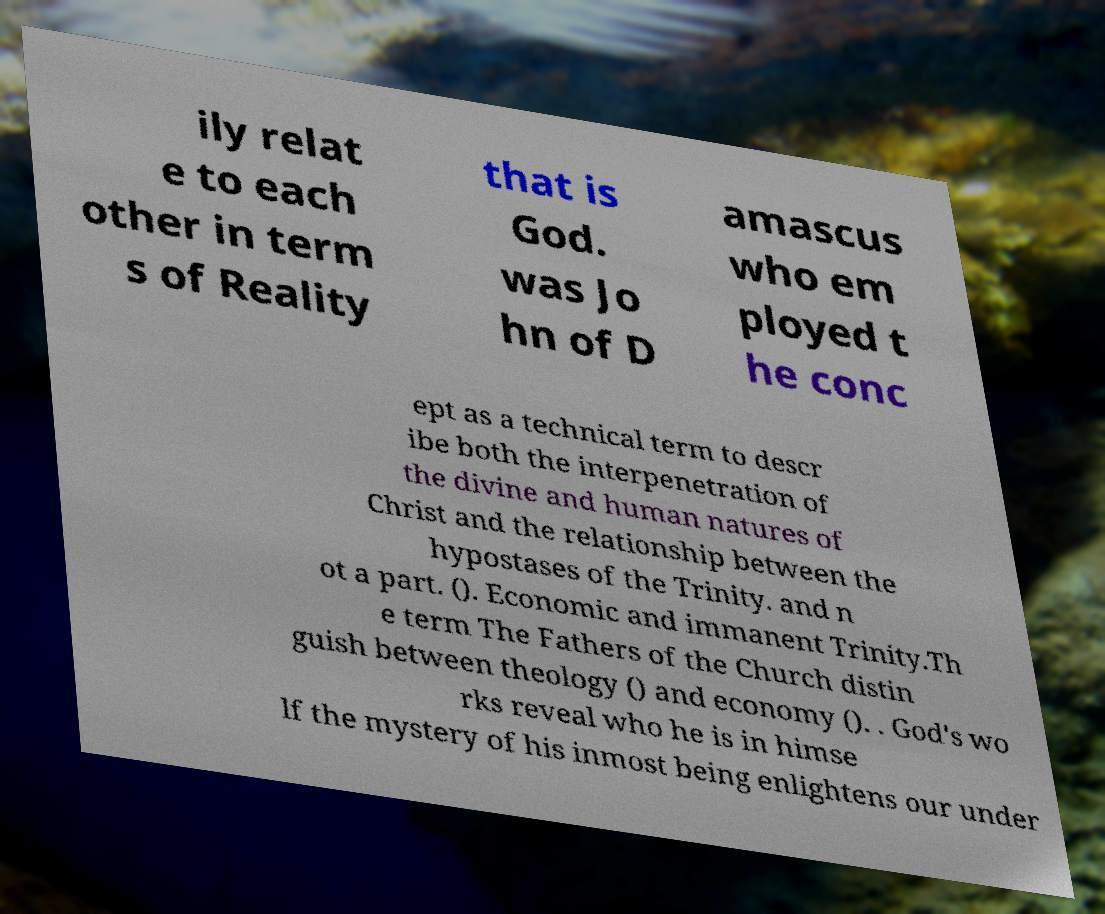Can you accurately transcribe the text from the provided image for me? ily relat e to each other in term s of Reality that is God. was Jo hn of D amascus who em ployed t he conc ept as a technical term to descr ibe both the interpenetration of the divine and human natures of Christ and the relationship between the hypostases of the Trinity. and n ot a part. (). Economic and immanent Trinity.Th e term The Fathers of the Church distin guish between theology () and economy (). . God's wo rks reveal who he is in himse lf the mystery of his inmost being enlightens our under 